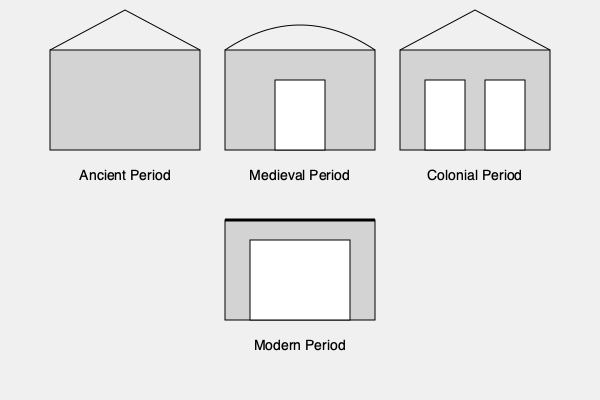Analyze the architectural styles depicted in the sketches above, representing different periods in Sri Lankan history. Identify the key features that distinguish each period and explain how these reflect the cultural and historical context of Sri Lanka. Which period shows the most significant foreign influence, and why? To answer this question, let's analyze each period's architectural style:

1. Ancient Period (top left):
   - Simple rectangular structure with a triangular roof
   - Resembles early Buddhist temples or monasteries
   - Reflects indigenous architectural traditions

2. Medieval Period (top center):
   - Rectangular structure with a curved roof
   - Larger windows or openings
   - Indicates evolving architectural styles, possibly influenced by South Indian traditions

3. Colonial Period (top right):
   - Rectangular structure with a triangular roof
   - Symmetrical design with multiple windows
   - Shows clear European influence, likely Dutch or British colonial architecture

4. Modern Period (bottom center):
   - Rectangular structure with a flat roof
   - Large windows or glass facades
   - Represents contemporary architectural trends

The Colonial Period shows the most significant foreign influence because:
   a) It deviates most from traditional Sri Lankan styles
   b) Incorporates distinctly European elements (symmetry, multiple windows)
   c) Reflects the direct impact of colonial rule on Sri Lankan architecture

This architectural evolution reflects Sri Lanka's rich history:
   - Ancient period: Early Buddhist influence and indigenous styles
   - Medieval period: Growing regional influences and evolving local traditions
   - Colonial period: European occupation and cultural imposition
   - Modern period: Global architectural trends and functional design

The colonial architecture's prominence demonstrates the lasting impact of European rule on Sri Lankan culture and built environment.
Answer: Colonial Period; European design elements reflect direct foreign rule and cultural imposition. 